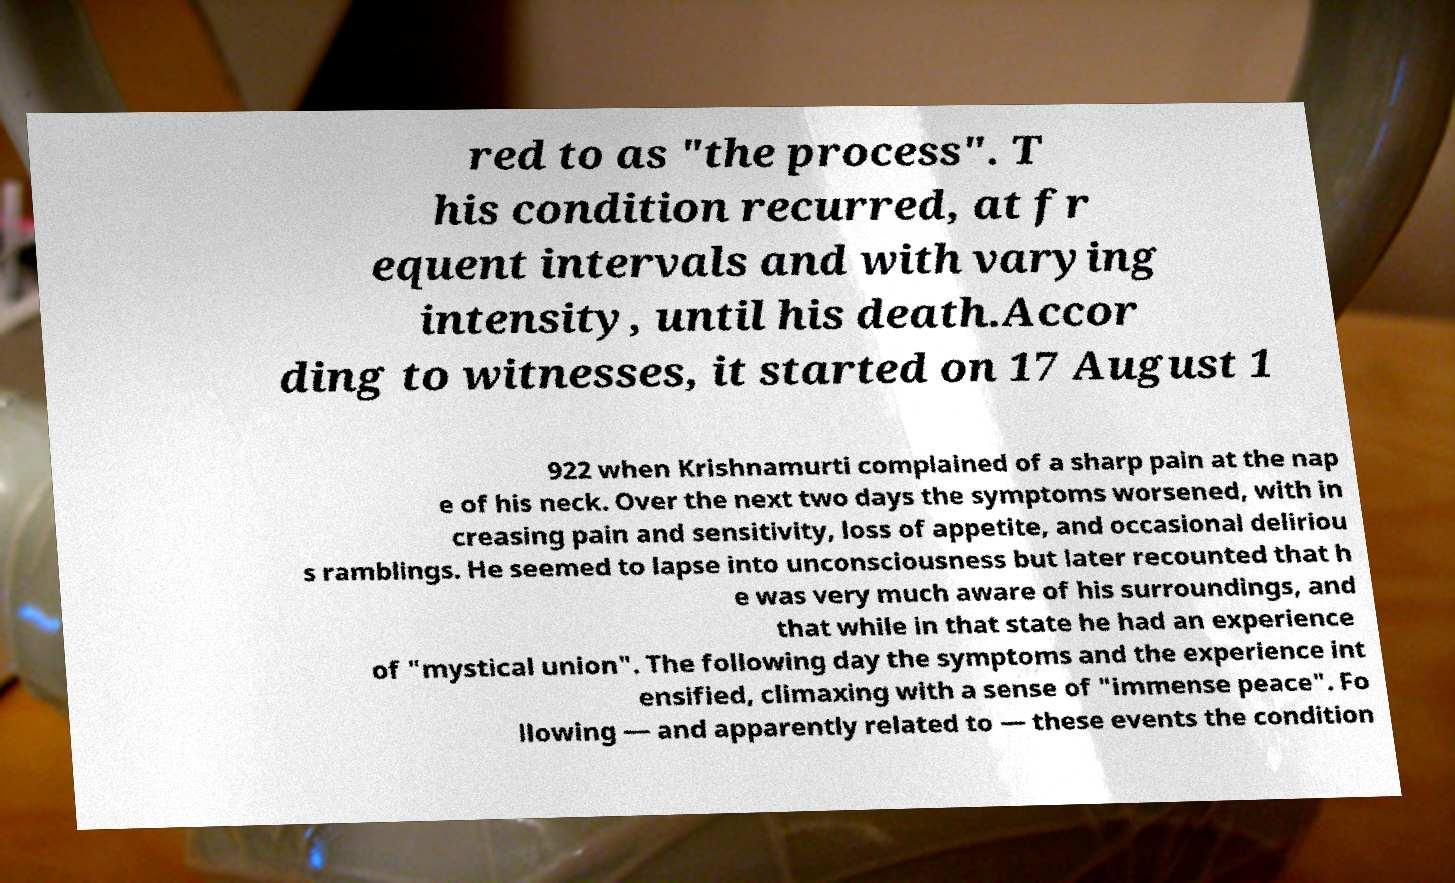Could you assist in decoding the text presented in this image and type it out clearly? red to as "the process". T his condition recurred, at fr equent intervals and with varying intensity, until his death.Accor ding to witnesses, it started on 17 August 1 922 when Krishnamurti complained of a sharp pain at the nap e of his neck. Over the next two days the symptoms worsened, with in creasing pain and sensitivity, loss of appetite, and occasional deliriou s ramblings. He seemed to lapse into unconsciousness but later recounted that h e was very much aware of his surroundings, and that while in that state he had an experience of "mystical union". The following day the symptoms and the experience int ensified, climaxing with a sense of "immense peace". Fo llowing — and apparently related to — these events the condition 